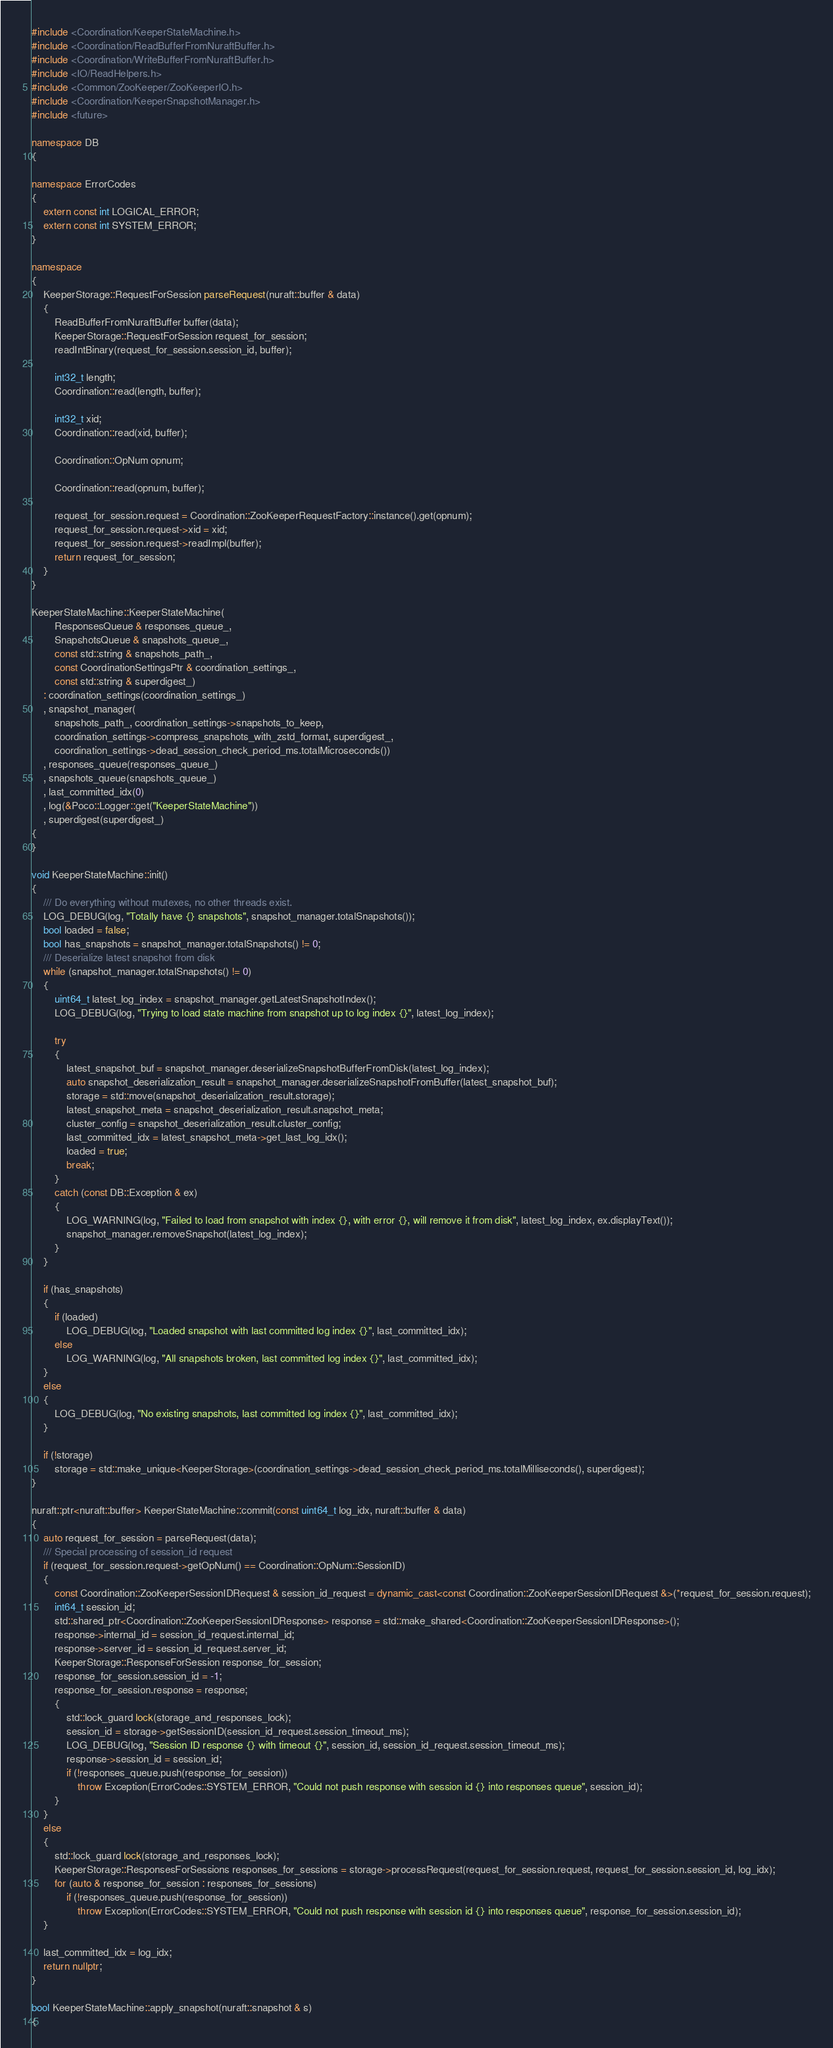Convert code to text. <code><loc_0><loc_0><loc_500><loc_500><_C++_>#include <Coordination/KeeperStateMachine.h>
#include <Coordination/ReadBufferFromNuraftBuffer.h>
#include <Coordination/WriteBufferFromNuraftBuffer.h>
#include <IO/ReadHelpers.h>
#include <Common/ZooKeeper/ZooKeeperIO.h>
#include <Coordination/KeeperSnapshotManager.h>
#include <future>

namespace DB
{

namespace ErrorCodes
{
    extern const int LOGICAL_ERROR;
    extern const int SYSTEM_ERROR;
}

namespace
{
    KeeperStorage::RequestForSession parseRequest(nuraft::buffer & data)
    {
        ReadBufferFromNuraftBuffer buffer(data);
        KeeperStorage::RequestForSession request_for_session;
        readIntBinary(request_for_session.session_id, buffer);

        int32_t length;
        Coordination::read(length, buffer);

        int32_t xid;
        Coordination::read(xid, buffer);

        Coordination::OpNum opnum;

        Coordination::read(opnum, buffer);

        request_for_session.request = Coordination::ZooKeeperRequestFactory::instance().get(opnum);
        request_for_session.request->xid = xid;
        request_for_session.request->readImpl(buffer);
        return request_for_session;
    }
}

KeeperStateMachine::KeeperStateMachine(
        ResponsesQueue & responses_queue_,
        SnapshotsQueue & snapshots_queue_,
        const std::string & snapshots_path_,
        const CoordinationSettingsPtr & coordination_settings_,
        const std::string & superdigest_)
    : coordination_settings(coordination_settings_)
    , snapshot_manager(
        snapshots_path_, coordination_settings->snapshots_to_keep,
        coordination_settings->compress_snapshots_with_zstd_format, superdigest_,
        coordination_settings->dead_session_check_period_ms.totalMicroseconds())
    , responses_queue(responses_queue_)
    , snapshots_queue(snapshots_queue_)
    , last_committed_idx(0)
    , log(&Poco::Logger::get("KeeperStateMachine"))
    , superdigest(superdigest_)
{
}

void KeeperStateMachine::init()
{
    /// Do everything without mutexes, no other threads exist.
    LOG_DEBUG(log, "Totally have {} snapshots", snapshot_manager.totalSnapshots());
    bool loaded = false;
    bool has_snapshots = snapshot_manager.totalSnapshots() != 0;
    /// Deserialize latest snapshot from disk
    while (snapshot_manager.totalSnapshots() != 0)
    {
        uint64_t latest_log_index = snapshot_manager.getLatestSnapshotIndex();
        LOG_DEBUG(log, "Trying to load state machine from snapshot up to log index {}", latest_log_index);

        try
        {
            latest_snapshot_buf = snapshot_manager.deserializeSnapshotBufferFromDisk(latest_log_index);
            auto snapshot_deserialization_result = snapshot_manager.deserializeSnapshotFromBuffer(latest_snapshot_buf);
            storage = std::move(snapshot_deserialization_result.storage);
            latest_snapshot_meta = snapshot_deserialization_result.snapshot_meta;
            cluster_config = snapshot_deserialization_result.cluster_config;
            last_committed_idx = latest_snapshot_meta->get_last_log_idx();
            loaded = true;
            break;
        }
        catch (const DB::Exception & ex)
        {
            LOG_WARNING(log, "Failed to load from snapshot with index {}, with error {}, will remove it from disk", latest_log_index, ex.displayText());
            snapshot_manager.removeSnapshot(latest_log_index);
        }
    }

    if (has_snapshots)
    {
        if (loaded)
            LOG_DEBUG(log, "Loaded snapshot with last committed log index {}", last_committed_idx);
        else
            LOG_WARNING(log, "All snapshots broken, last committed log index {}", last_committed_idx);
    }
    else
    {
        LOG_DEBUG(log, "No existing snapshots, last committed log index {}", last_committed_idx);
    }

    if (!storage)
        storage = std::make_unique<KeeperStorage>(coordination_settings->dead_session_check_period_ms.totalMilliseconds(), superdigest);
}

nuraft::ptr<nuraft::buffer> KeeperStateMachine::commit(const uint64_t log_idx, nuraft::buffer & data)
{
    auto request_for_session = parseRequest(data);
    /// Special processing of session_id request
    if (request_for_session.request->getOpNum() == Coordination::OpNum::SessionID)
    {
        const Coordination::ZooKeeperSessionIDRequest & session_id_request = dynamic_cast<const Coordination::ZooKeeperSessionIDRequest &>(*request_for_session.request);
        int64_t session_id;
        std::shared_ptr<Coordination::ZooKeeperSessionIDResponse> response = std::make_shared<Coordination::ZooKeeperSessionIDResponse>();
        response->internal_id = session_id_request.internal_id;
        response->server_id = session_id_request.server_id;
        KeeperStorage::ResponseForSession response_for_session;
        response_for_session.session_id = -1;
        response_for_session.response = response;
        {
            std::lock_guard lock(storage_and_responses_lock);
            session_id = storage->getSessionID(session_id_request.session_timeout_ms);
            LOG_DEBUG(log, "Session ID response {} with timeout {}", session_id, session_id_request.session_timeout_ms);
            response->session_id = session_id;
            if (!responses_queue.push(response_for_session))
                throw Exception(ErrorCodes::SYSTEM_ERROR, "Could not push response with session id {} into responses queue", session_id);
        }
    }
    else
    {
        std::lock_guard lock(storage_and_responses_lock);
        KeeperStorage::ResponsesForSessions responses_for_sessions = storage->processRequest(request_for_session.request, request_for_session.session_id, log_idx);
        for (auto & response_for_session : responses_for_sessions)
            if (!responses_queue.push(response_for_session))
                throw Exception(ErrorCodes::SYSTEM_ERROR, "Could not push response with session id {} into responses queue", response_for_session.session_id);
    }

    last_committed_idx = log_idx;
    return nullptr;
}

bool KeeperStateMachine::apply_snapshot(nuraft::snapshot & s)
{</code> 